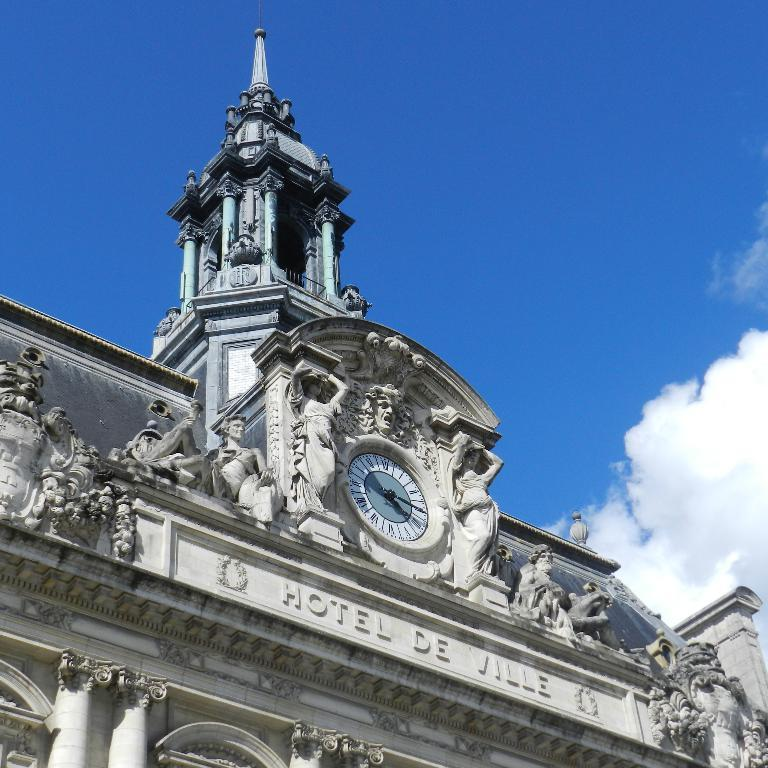<image>
Relay a brief, clear account of the picture shown. a clock tower and the facade of a building that say Hotel de Ville 